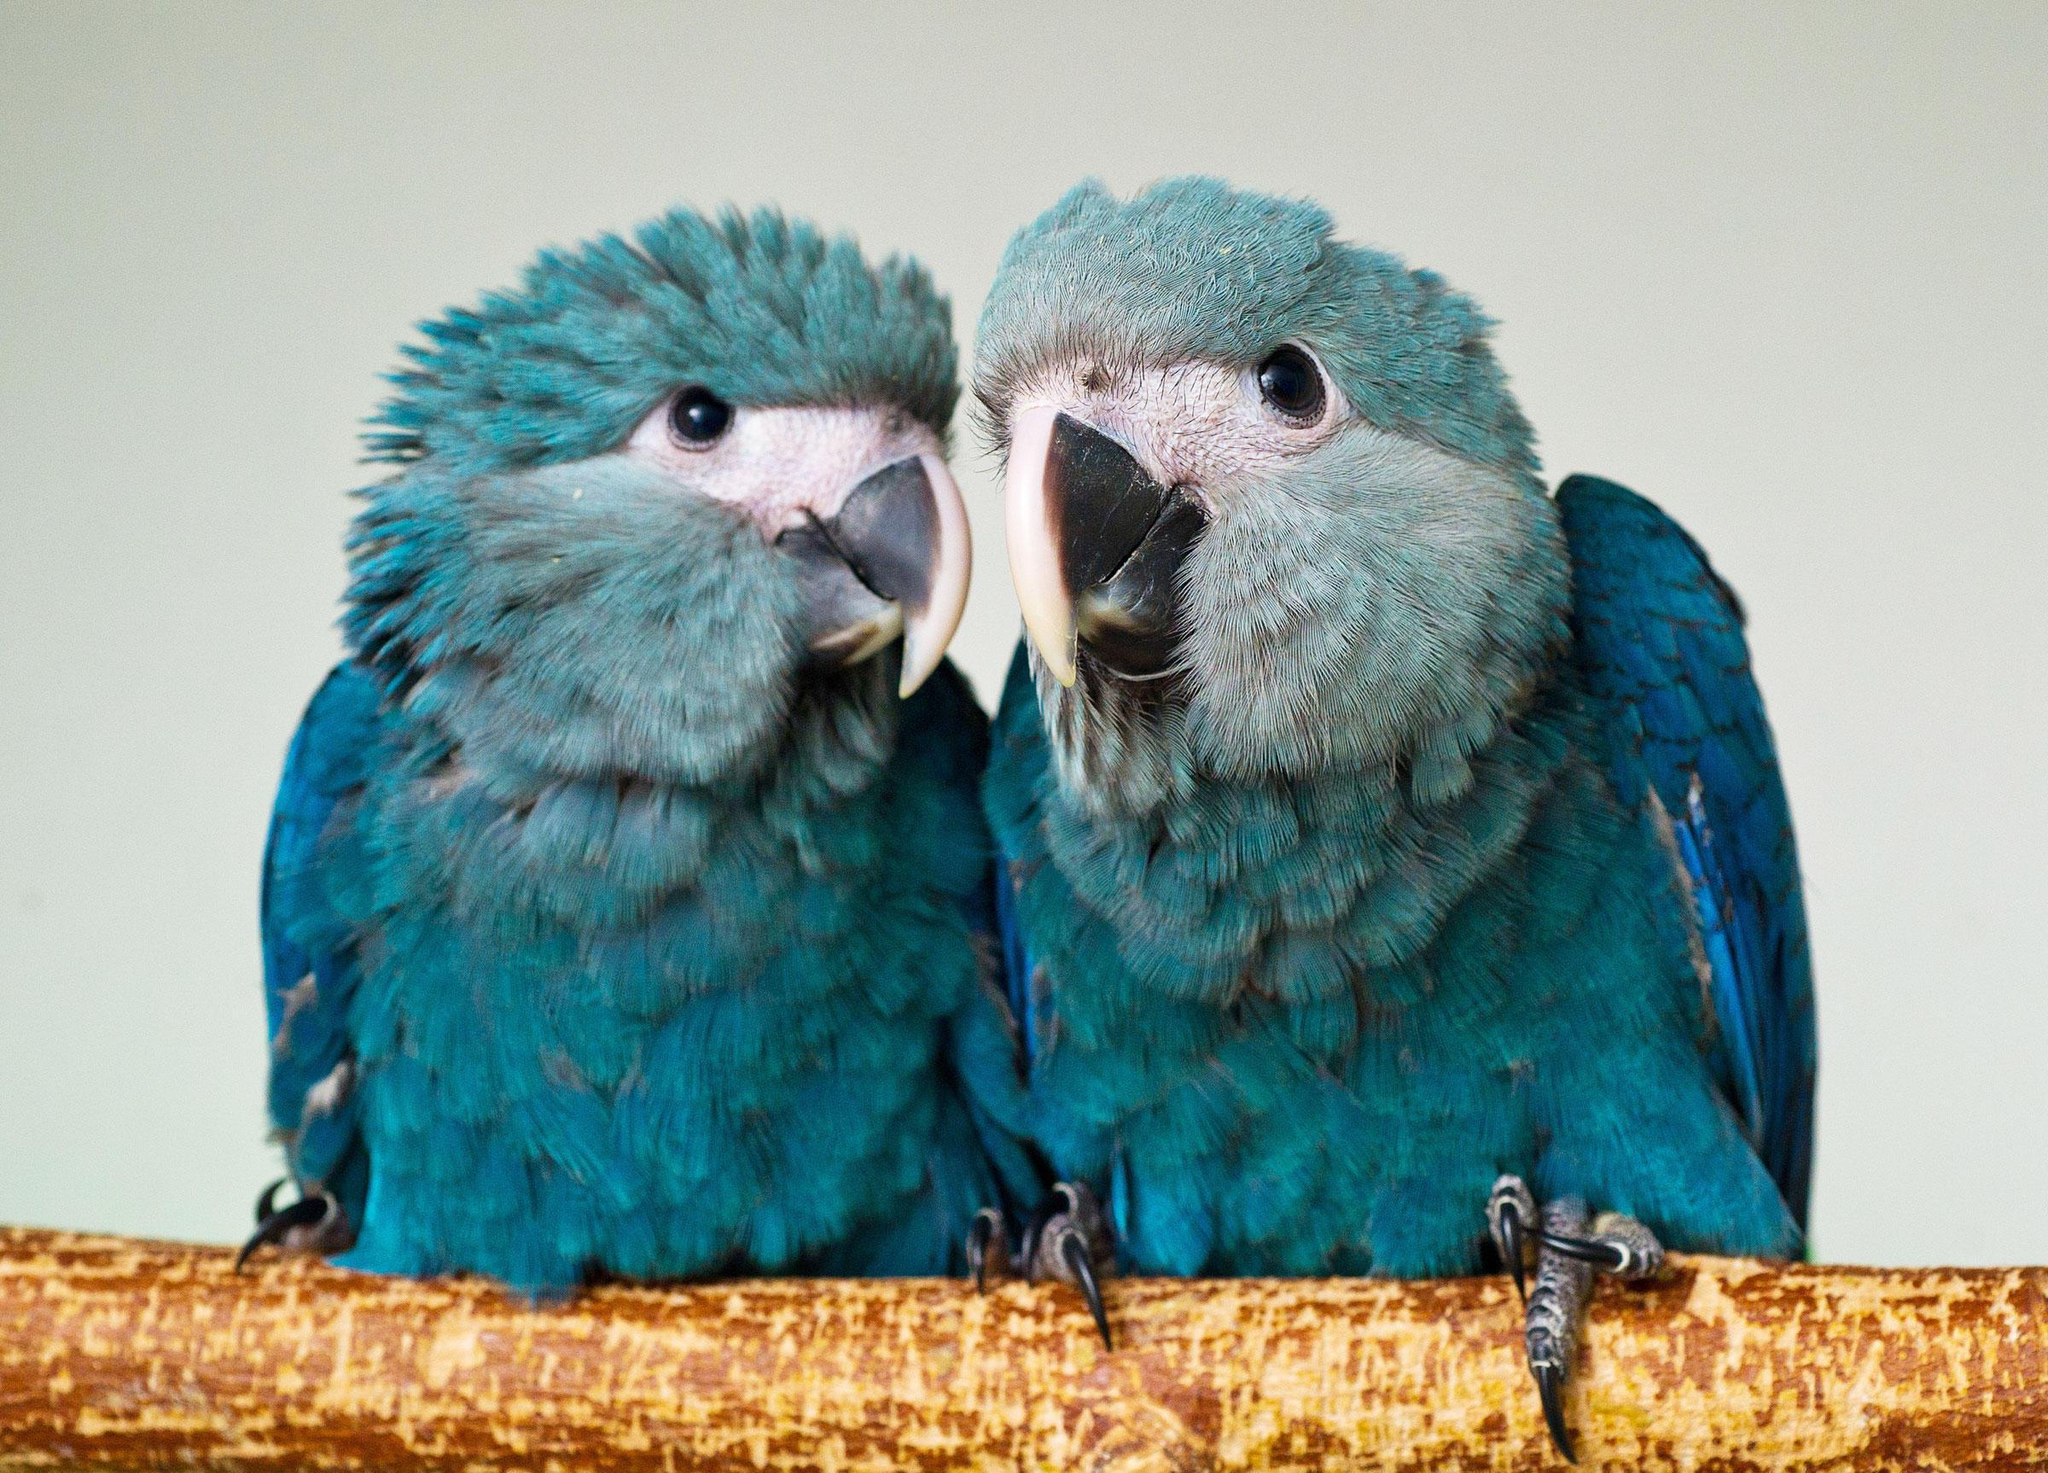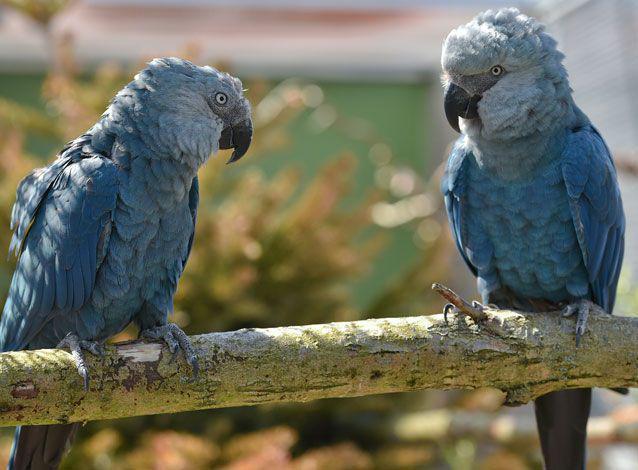The first image is the image on the left, the second image is the image on the right. Assess this claim about the two images: "All of the birds sit on a branch with a blue background behind them.". Correct or not? Answer yes or no. No. 